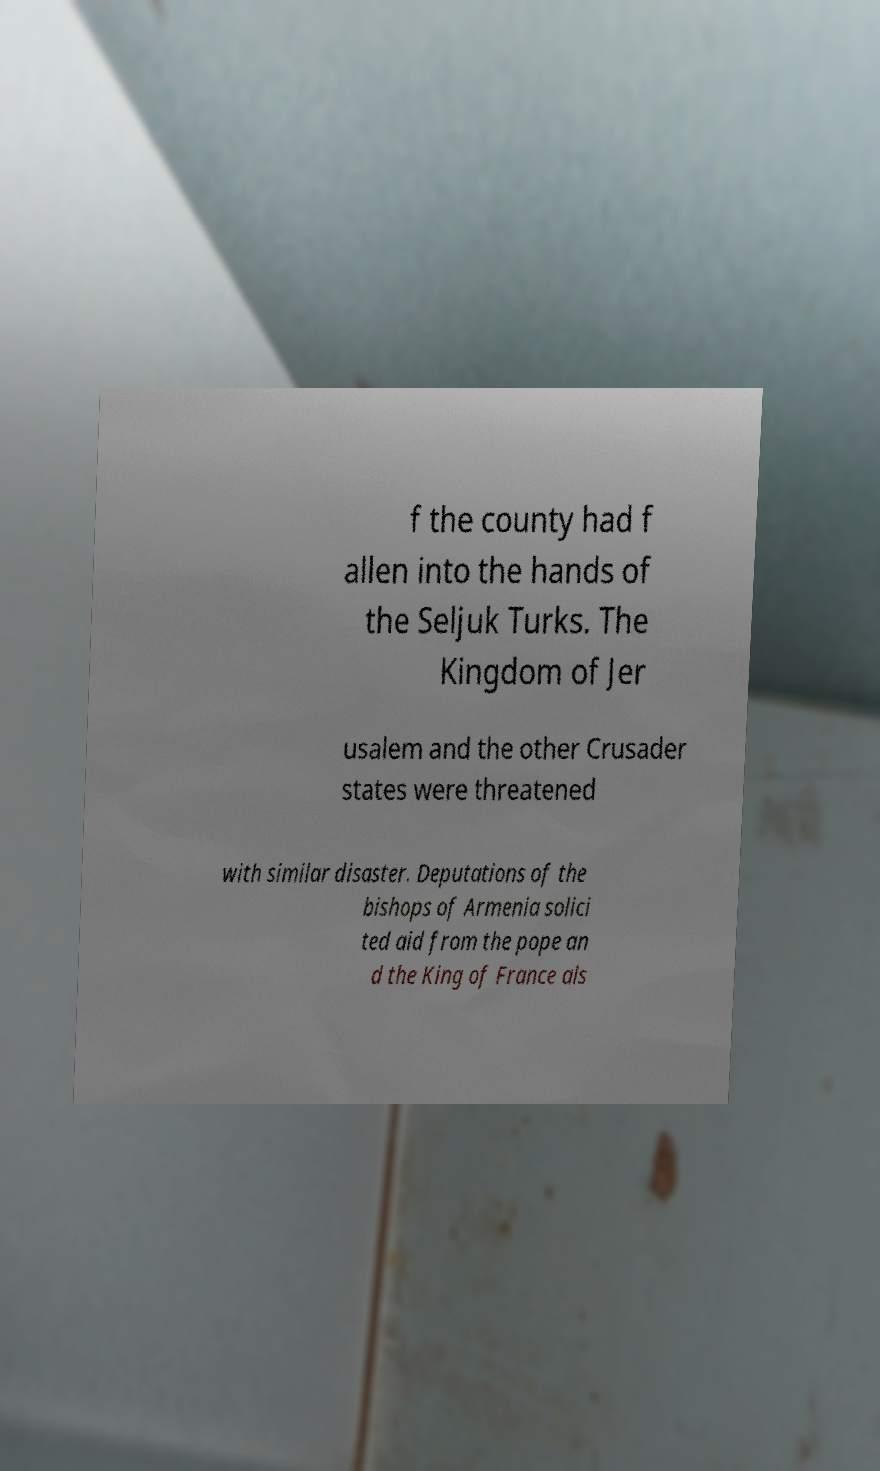Could you extract and type out the text from this image? f the county had f allen into the hands of the Seljuk Turks. The Kingdom of Jer usalem and the other Crusader states were threatened with similar disaster. Deputations of the bishops of Armenia solici ted aid from the pope an d the King of France als 